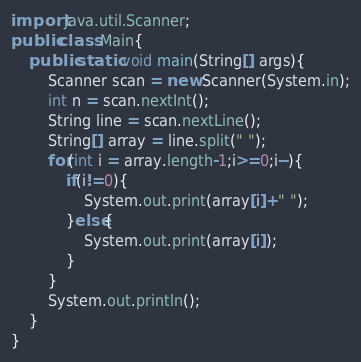Convert code to text. <code><loc_0><loc_0><loc_500><loc_500><_Java_>import java.util.Scanner;
public class Main{
	public static void main(String[] args){
		Scanner scan = new Scanner(System.in);
		int n = scan.nextInt();
		String line = scan.nextLine();
		String[] array = line.split(" ");
		for(int i = array.length-1;i>=0;i--){
			if(i!=0){
				System.out.print(array[i]+" ");
			}else{
				System.out.print(array[i]);
			}
		}
		System.out.println();
	}
}</code> 